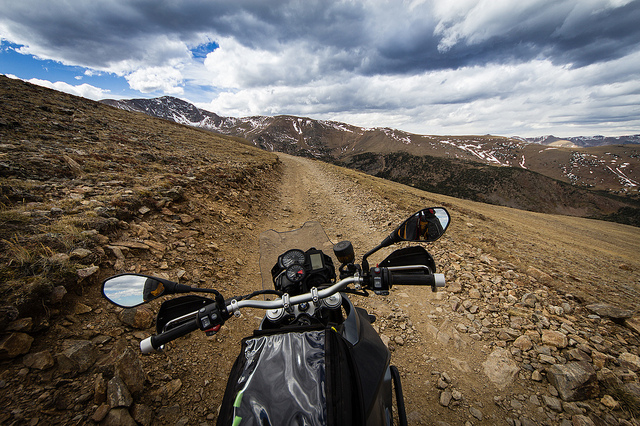Is the bike parked in the middle of nowhere? Yes, the bike is parked on a remote dirt road with no signs of civilization in the immediate vicinity, surrounded by wild terrain that appears rarely traveled. 